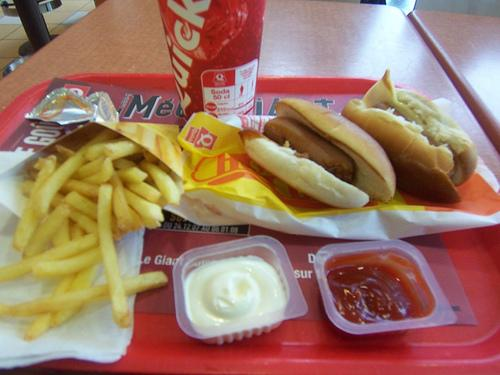What is being dipped in the red sauce? Please explain your reasoning. fries. Fries go in ketchup. 